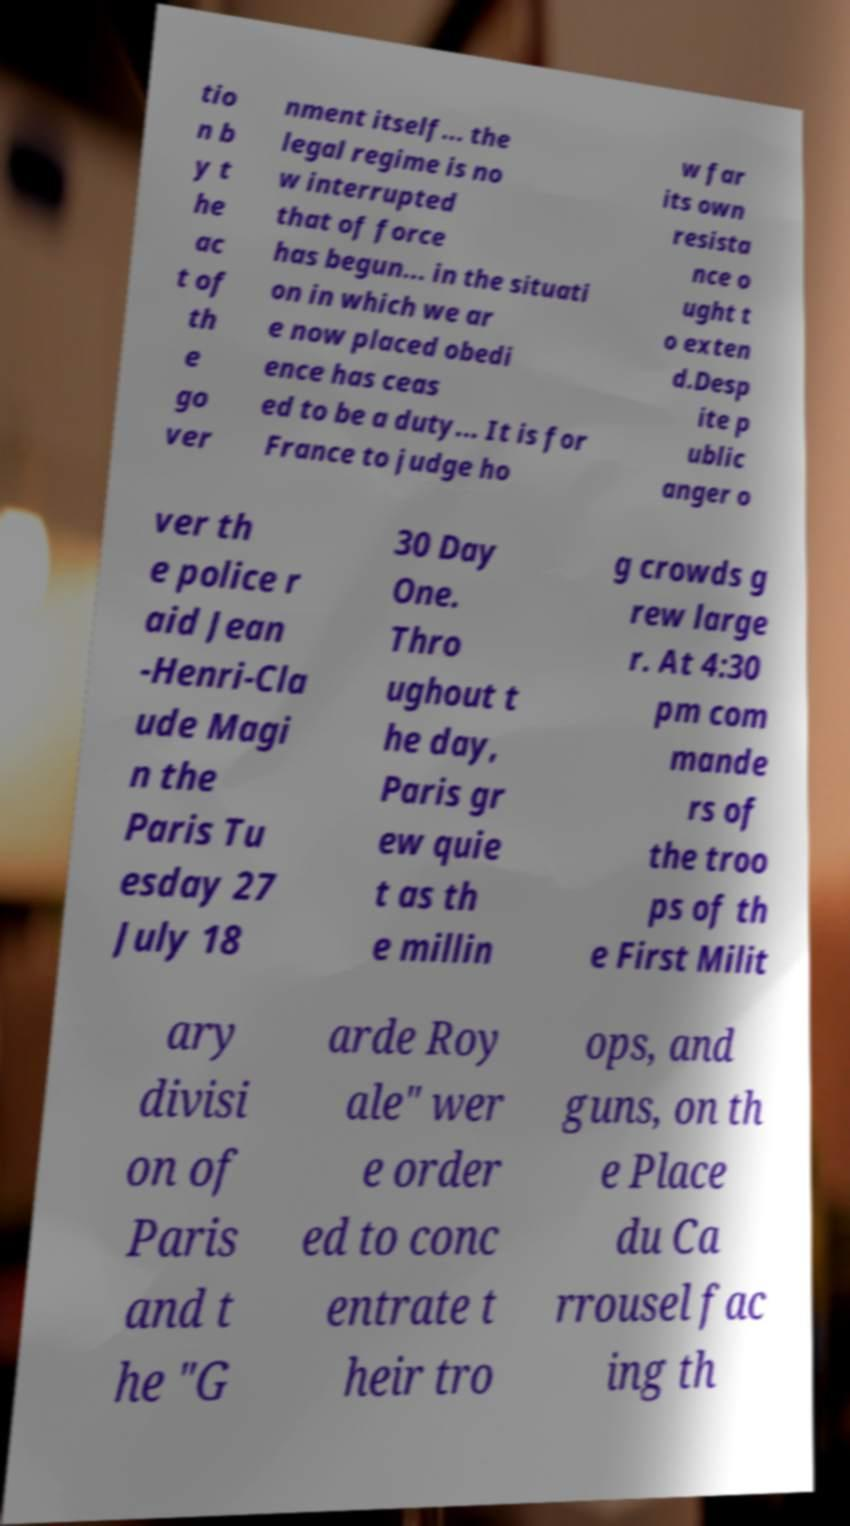Please identify and transcribe the text found in this image. tio n b y t he ac t of th e go ver nment itself... the legal regime is no w interrupted that of force has begun... in the situati on in which we ar e now placed obedi ence has ceas ed to be a duty... It is for France to judge ho w far its own resista nce o ught t o exten d.Desp ite p ublic anger o ver th e police r aid Jean -Henri-Cla ude Magi n the Paris Tu esday 27 July 18 30 Day One. Thro ughout t he day, Paris gr ew quie t as th e millin g crowds g rew large r. At 4:30 pm com mande rs of the troo ps of th e First Milit ary divisi on of Paris and t he "G arde Roy ale" wer e order ed to conc entrate t heir tro ops, and guns, on th e Place du Ca rrousel fac ing th 